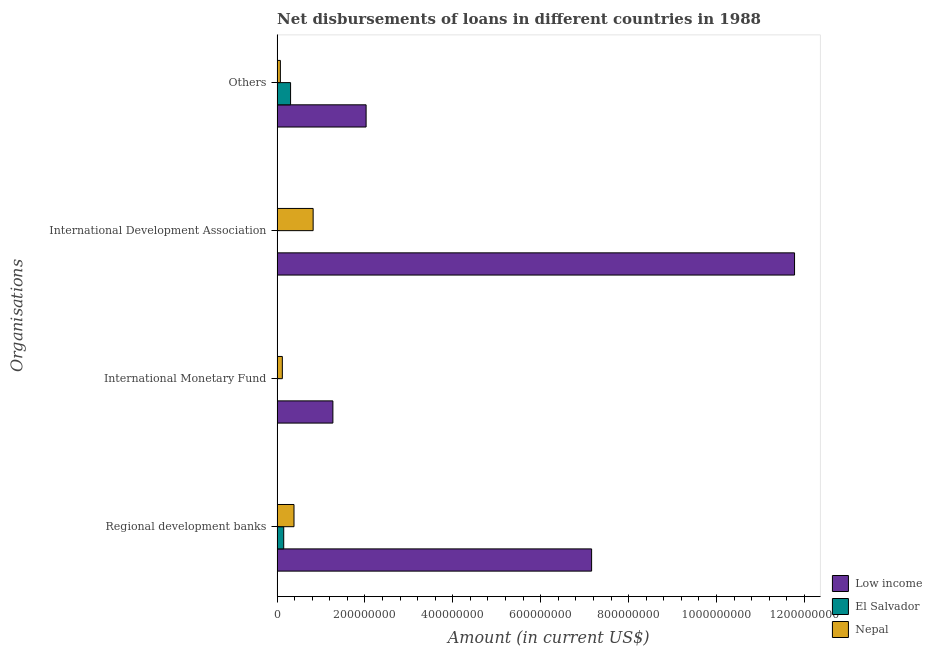Are the number of bars per tick equal to the number of legend labels?
Provide a short and direct response. No. Are the number of bars on each tick of the Y-axis equal?
Your response must be concise. No. How many bars are there on the 3rd tick from the bottom?
Ensure brevity in your answer.  2. What is the label of the 1st group of bars from the top?
Ensure brevity in your answer.  Others. What is the amount of loan disimbursed by other organisations in Low income?
Ensure brevity in your answer.  2.03e+08. Across all countries, what is the maximum amount of loan disimbursed by regional development banks?
Your response must be concise. 7.16e+08. Across all countries, what is the minimum amount of loan disimbursed by other organisations?
Keep it short and to the point. 7.39e+06. What is the total amount of loan disimbursed by regional development banks in the graph?
Offer a very short reply. 7.69e+08. What is the difference between the amount of loan disimbursed by other organisations in Nepal and that in Low income?
Your answer should be very brief. -1.95e+08. What is the difference between the amount of loan disimbursed by international monetary fund in Low income and the amount of loan disimbursed by international development association in El Salvador?
Ensure brevity in your answer.  1.27e+08. What is the average amount of loan disimbursed by international monetary fund per country?
Your answer should be compact. 4.63e+07. What is the difference between the amount of loan disimbursed by regional development banks and amount of loan disimbursed by other organisations in El Salvador?
Your response must be concise. -1.56e+07. What is the ratio of the amount of loan disimbursed by regional development banks in Low income to that in Nepal?
Ensure brevity in your answer.  18.64. What is the difference between the highest and the second highest amount of loan disimbursed by other organisations?
Provide a succinct answer. 1.72e+08. What is the difference between the highest and the lowest amount of loan disimbursed by regional development banks?
Provide a succinct answer. 7.01e+08. Is the sum of the amount of loan disimbursed by international development association in Nepal and Low income greater than the maximum amount of loan disimbursed by other organisations across all countries?
Offer a very short reply. Yes. Is it the case that in every country, the sum of the amount of loan disimbursed by other organisations and amount of loan disimbursed by regional development banks is greater than the sum of amount of loan disimbursed by international monetary fund and amount of loan disimbursed by international development association?
Offer a very short reply. No. Is it the case that in every country, the sum of the amount of loan disimbursed by regional development banks and amount of loan disimbursed by international monetary fund is greater than the amount of loan disimbursed by international development association?
Offer a very short reply. No. What is the difference between two consecutive major ticks on the X-axis?
Your answer should be very brief. 2.00e+08. Does the graph contain grids?
Keep it short and to the point. No. Where does the legend appear in the graph?
Offer a terse response. Bottom right. What is the title of the graph?
Offer a very short reply. Net disbursements of loans in different countries in 1988. Does "Sub-Saharan Africa (all income levels)" appear as one of the legend labels in the graph?
Your response must be concise. No. What is the label or title of the X-axis?
Provide a short and direct response. Amount (in current US$). What is the label or title of the Y-axis?
Provide a succinct answer. Organisations. What is the Amount (in current US$) in Low income in Regional development banks?
Keep it short and to the point. 7.16e+08. What is the Amount (in current US$) of El Salvador in Regional development banks?
Provide a succinct answer. 1.50e+07. What is the Amount (in current US$) of Nepal in Regional development banks?
Provide a succinct answer. 3.84e+07. What is the Amount (in current US$) in Low income in International Monetary Fund?
Offer a very short reply. 1.27e+08. What is the Amount (in current US$) in El Salvador in International Monetary Fund?
Offer a terse response. 0. What is the Amount (in current US$) of Nepal in International Monetary Fund?
Your response must be concise. 1.19e+07. What is the Amount (in current US$) in Low income in International Development Association?
Offer a very short reply. 1.18e+09. What is the Amount (in current US$) in El Salvador in International Development Association?
Make the answer very short. 0. What is the Amount (in current US$) of Nepal in International Development Association?
Keep it short and to the point. 8.20e+07. What is the Amount (in current US$) in Low income in Others?
Give a very brief answer. 2.03e+08. What is the Amount (in current US$) of El Salvador in Others?
Ensure brevity in your answer.  3.06e+07. What is the Amount (in current US$) in Nepal in Others?
Keep it short and to the point. 7.39e+06. Across all Organisations, what is the maximum Amount (in current US$) in Low income?
Make the answer very short. 1.18e+09. Across all Organisations, what is the maximum Amount (in current US$) of El Salvador?
Offer a very short reply. 3.06e+07. Across all Organisations, what is the maximum Amount (in current US$) of Nepal?
Provide a succinct answer. 8.20e+07. Across all Organisations, what is the minimum Amount (in current US$) of Low income?
Your answer should be compact. 1.27e+08. Across all Organisations, what is the minimum Amount (in current US$) in Nepal?
Keep it short and to the point. 7.39e+06. What is the total Amount (in current US$) of Low income in the graph?
Provide a succinct answer. 2.22e+09. What is the total Amount (in current US$) of El Salvador in the graph?
Your answer should be compact. 4.56e+07. What is the total Amount (in current US$) of Nepal in the graph?
Keep it short and to the point. 1.40e+08. What is the difference between the Amount (in current US$) in Low income in Regional development banks and that in International Monetary Fund?
Keep it short and to the point. 5.89e+08. What is the difference between the Amount (in current US$) in Nepal in Regional development banks and that in International Monetary Fund?
Your answer should be compact. 2.65e+07. What is the difference between the Amount (in current US$) of Low income in Regional development banks and that in International Development Association?
Make the answer very short. -4.62e+08. What is the difference between the Amount (in current US$) of Nepal in Regional development banks and that in International Development Association?
Provide a short and direct response. -4.36e+07. What is the difference between the Amount (in current US$) of Low income in Regional development banks and that in Others?
Offer a very short reply. 5.13e+08. What is the difference between the Amount (in current US$) of El Salvador in Regional development banks and that in Others?
Your answer should be very brief. -1.56e+07. What is the difference between the Amount (in current US$) of Nepal in Regional development banks and that in Others?
Provide a short and direct response. 3.10e+07. What is the difference between the Amount (in current US$) of Low income in International Monetary Fund and that in International Development Association?
Provide a succinct answer. -1.05e+09. What is the difference between the Amount (in current US$) in Nepal in International Monetary Fund and that in International Development Association?
Keep it short and to the point. -7.01e+07. What is the difference between the Amount (in current US$) of Low income in International Monetary Fund and that in Others?
Provide a succinct answer. -7.56e+07. What is the difference between the Amount (in current US$) in Nepal in International Monetary Fund and that in Others?
Provide a short and direct response. 4.51e+06. What is the difference between the Amount (in current US$) of Low income in International Development Association and that in Others?
Make the answer very short. 9.75e+08. What is the difference between the Amount (in current US$) of Nepal in International Development Association and that in Others?
Your response must be concise. 7.46e+07. What is the difference between the Amount (in current US$) in Low income in Regional development banks and the Amount (in current US$) in Nepal in International Monetary Fund?
Your answer should be compact. 7.04e+08. What is the difference between the Amount (in current US$) of El Salvador in Regional development banks and the Amount (in current US$) of Nepal in International Monetary Fund?
Provide a succinct answer. 3.11e+06. What is the difference between the Amount (in current US$) in Low income in Regional development banks and the Amount (in current US$) in Nepal in International Development Association?
Your response must be concise. 6.34e+08. What is the difference between the Amount (in current US$) in El Salvador in Regional development banks and the Amount (in current US$) in Nepal in International Development Association?
Ensure brevity in your answer.  -6.70e+07. What is the difference between the Amount (in current US$) in Low income in Regional development banks and the Amount (in current US$) in El Salvador in Others?
Give a very brief answer. 6.85e+08. What is the difference between the Amount (in current US$) of Low income in Regional development banks and the Amount (in current US$) of Nepal in Others?
Your response must be concise. 7.08e+08. What is the difference between the Amount (in current US$) in El Salvador in Regional development banks and the Amount (in current US$) in Nepal in Others?
Make the answer very short. 7.62e+06. What is the difference between the Amount (in current US$) of Low income in International Monetary Fund and the Amount (in current US$) of Nepal in International Development Association?
Ensure brevity in your answer.  4.50e+07. What is the difference between the Amount (in current US$) of Low income in International Monetary Fund and the Amount (in current US$) of El Salvador in Others?
Provide a short and direct response. 9.63e+07. What is the difference between the Amount (in current US$) in Low income in International Monetary Fund and the Amount (in current US$) in Nepal in Others?
Your answer should be compact. 1.20e+08. What is the difference between the Amount (in current US$) in Low income in International Development Association and the Amount (in current US$) in El Salvador in Others?
Your answer should be compact. 1.15e+09. What is the difference between the Amount (in current US$) of Low income in International Development Association and the Amount (in current US$) of Nepal in Others?
Provide a short and direct response. 1.17e+09. What is the average Amount (in current US$) in Low income per Organisations?
Give a very brief answer. 5.56e+08. What is the average Amount (in current US$) in El Salvador per Organisations?
Ensure brevity in your answer.  1.14e+07. What is the average Amount (in current US$) in Nepal per Organisations?
Offer a very short reply. 3.49e+07. What is the difference between the Amount (in current US$) of Low income and Amount (in current US$) of El Salvador in Regional development banks?
Offer a very short reply. 7.01e+08. What is the difference between the Amount (in current US$) in Low income and Amount (in current US$) in Nepal in Regional development banks?
Provide a short and direct response. 6.77e+08. What is the difference between the Amount (in current US$) of El Salvador and Amount (in current US$) of Nepal in Regional development banks?
Give a very brief answer. -2.34e+07. What is the difference between the Amount (in current US$) in Low income and Amount (in current US$) in Nepal in International Monetary Fund?
Provide a succinct answer. 1.15e+08. What is the difference between the Amount (in current US$) in Low income and Amount (in current US$) in Nepal in International Development Association?
Make the answer very short. 1.10e+09. What is the difference between the Amount (in current US$) in Low income and Amount (in current US$) in El Salvador in Others?
Provide a succinct answer. 1.72e+08. What is the difference between the Amount (in current US$) in Low income and Amount (in current US$) in Nepal in Others?
Your answer should be very brief. 1.95e+08. What is the difference between the Amount (in current US$) in El Salvador and Amount (in current US$) in Nepal in Others?
Ensure brevity in your answer.  2.32e+07. What is the ratio of the Amount (in current US$) in Low income in Regional development banks to that in International Monetary Fund?
Give a very brief answer. 5.64. What is the ratio of the Amount (in current US$) in Nepal in Regional development banks to that in International Monetary Fund?
Keep it short and to the point. 3.23. What is the ratio of the Amount (in current US$) in Low income in Regional development banks to that in International Development Association?
Ensure brevity in your answer.  0.61. What is the ratio of the Amount (in current US$) of Nepal in Regional development banks to that in International Development Association?
Provide a short and direct response. 0.47. What is the ratio of the Amount (in current US$) of Low income in Regional development banks to that in Others?
Provide a succinct answer. 3.53. What is the ratio of the Amount (in current US$) in El Salvador in Regional development banks to that in Others?
Keep it short and to the point. 0.49. What is the ratio of the Amount (in current US$) in Nepal in Regional development banks to that in Others?
Offer a terse response. 5.2. What is the ratio of the Amount (in current US$) in Low income in International Monetary Fund to that in International Development Association?
Your answer should be compact. 0.11. What is the ratio of the Amount (in current US$) of Nepal in International Monetary Fund to that in International Development Association?
Offer a terse response. 0.15. What is the ratio of the Amount (in current US$) in Low income in International Monetary Fund to that in Others?
Ensure brevity in your answer.  0.63. What is the ratio of the Amount (in current US$) of Nepal in International Monetary Fund to that in Others?
Give a very brief answer. 1.61. What is the ratio of the Amount (in current US$) in Low income in International Development Association to that in Others?
Your answer should be very brief. 5.82. What is the ratio of the Amount (in current US$) of Nepal in International Development Association to that in Others?
Your response must be concise. 11.1. What is the difference between the highest and the second highest Amount (in current US$) in Low income?
Keep it short and to the point. 4.62e+08. What is the difference between the highest and the second highest Amount (in current US$) in Nepal?
Keep it short and to the point. 4.36e+07. What is the difference between the highest and the lowest Amount (in current US$) of Low income?
Provide a short and direct response. 1.05e+09. What is the difference between the highest and the lowest Amount (in current US$) in El Salvador?
Keep it short and to the point. 3.06e+07. What is the difference between the highest and the lowest Amount (in current US$) in Nepal?
Your answer should be compact. 7.46e+07. 